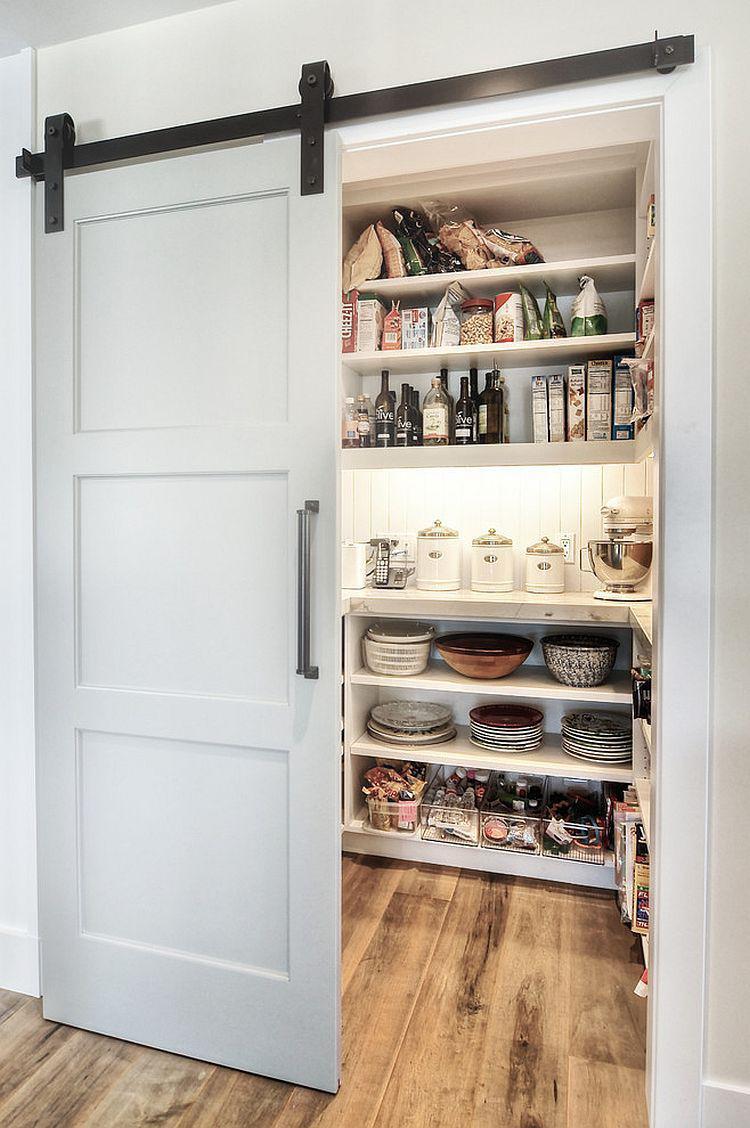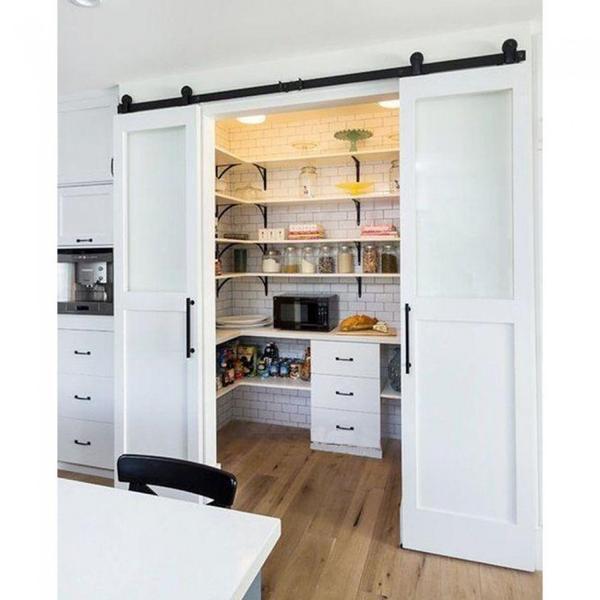The first image is the image on the left, the second image is the image on the right. For the images displayed, is the sentence "One image shows white barn-style double doors that slide on an overhead black bar, and the doors are open revealing filled shelves." factually correct? Answer yes or no. Yes. The first image is the image on the left, the second image is the image on the right. Given the left and right images, does the statement "The left and right image contains the same number of hanging doors." hold true? Answer yes or no. No. 